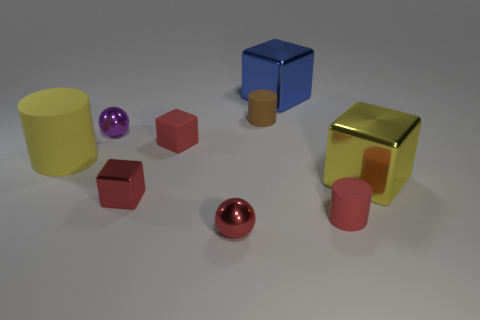There is a large shiny cube that is in front of the big blue shiny block; what color is it?
Your answer should be compact. Yellow. There is a small sphere that is the same color as the small shiny cube; what is its material?
Make the answer very short. Metal. There is a large yellow cube; are there any big yellow rubber objects on the right side of it?
Your response must be concise. No. Is the number of shiny objects greater than the number of big yellow cylinders?
Provide a succinct answer. Yes. There is a cylinder that is left of the tiny thing behind the metal sphere behind the yellow shiny thing; what color is it?
Keep it short and to the point. Yellow. The big thing that is the same material as the blue cube is what color?
Offer a terse response. Yellow. How many things are objects that are left of the small brown matte cylinder or red things that are behind the red shiny block?
Give a very brief answer. 5. There is a blue thing that is behind the large yellow shiny object; does it have the same size as the matte object in front of the large rubber cylinder?
Your answer should be very brief. No. There is a matte thing that is the same shape as the big yellow metallic thing; what color is it?
Keep it short and to the point. Red. Are there more big things that are in front of the large blue shiny thing than metal objects that are behind the small brown rubber cylinder?
Offer a terse response. Yes. 